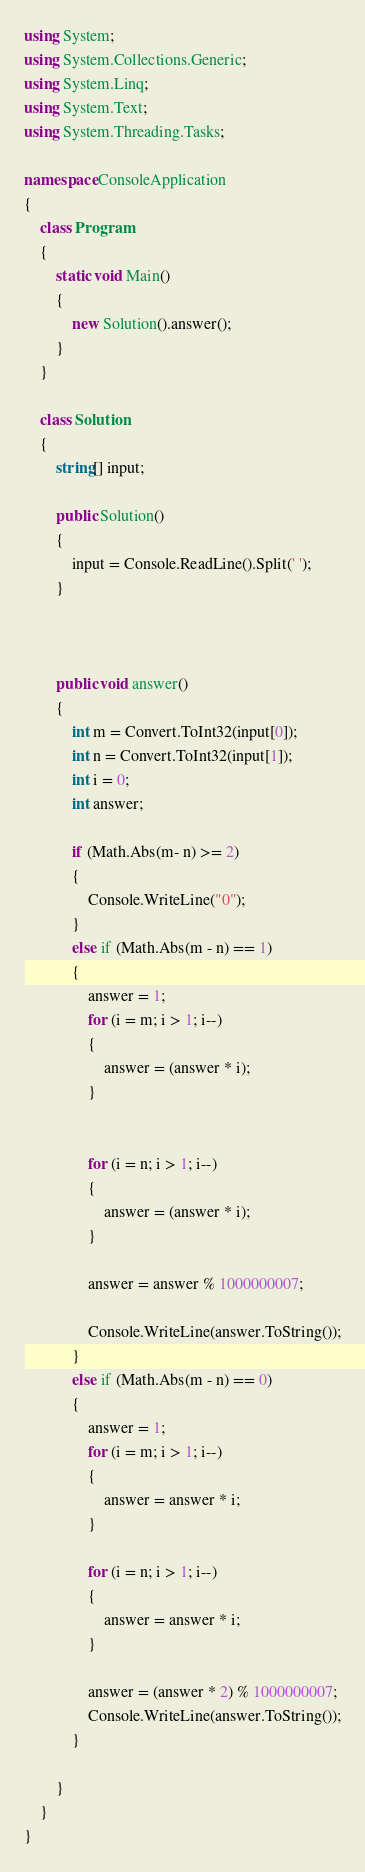Convert code to text. <code><loc_0><loc_0><loc_500><loc_500><_C#_>using System;
using System.Collections.Generic;
using System.Linq;
using System.Text;
using System.Threading.Tasks;

namespace ConsoleApplication
{
    class Program
    {
        static void Main()
        {
            new Solution().answer();
        }
    }

    class Solution
    {
        string[] input;

        public Solution()
        {
            input = Console.ReadLine().Split(' ');
        }
        


        public void answer()
        {
            int m = Convert.ToInt32(input[0]);
            int n = Convert.ToInt32(input[1]);
            int i = 0;
            int answer;

            if (Math.Abs(m- n) >= 2)
            {
                Console.WriteLine("0");
            }
            else if (Math.Abs(m - n) == 1)
            {
                answer = 1;
                for (i = m; i > 1; i--)
                {
                    answer = (answer * i);
                }
       

                for (i = n; i > 1; i--)
                {
                    answer = (answer * i);
                }

                answer = answer % 1000000007;

                Console.WriteLine(answer.ToString());
            }
            else if (Math.Abs(m - n) == 0)
            {
                answer = 1;
                for (i = m; i > 1; i--)
                {
                    answer = answer * i;
                }

                for (i = n; i > 1; i--)
                {
                    answer = answer * i;
                }

                answer = (answer * 2) % 1000000007;
                Console.WriteLine(answer.ToString());
            }

        }
    }
}</code> 